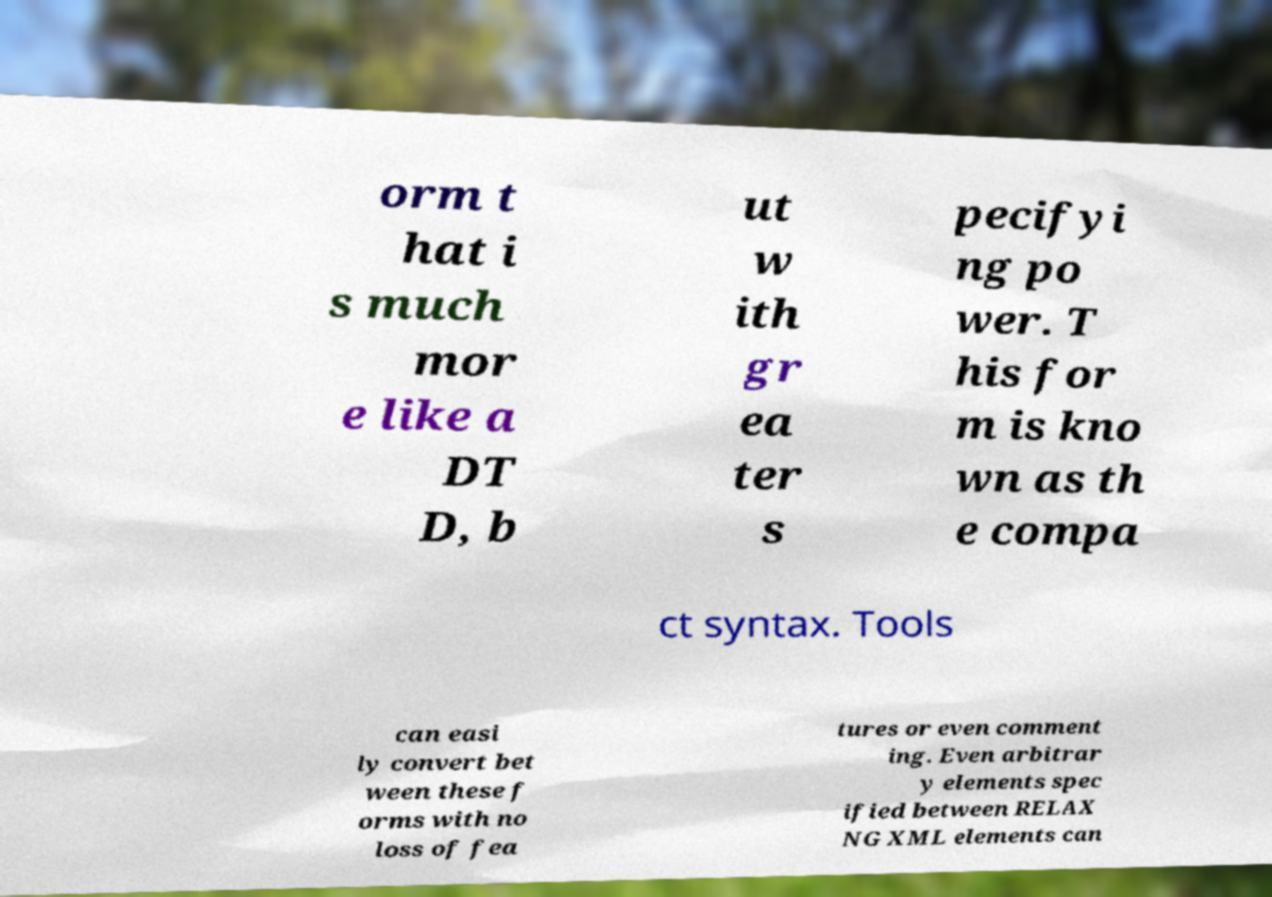For documentation purposes, I need the text within this image transcribed. Could you provide that? orm t hat i s much mor e like a DT D, b ut w ith gr ea ter s pecifyi ng po wer. T his for m is kno wn as th e compa ct syntax. Tools can easi ly convert bet ween these f orms with no loss of fea tures or even comment ing. Even arbitrar y elements spec ified between RELAX NG XML elements can 